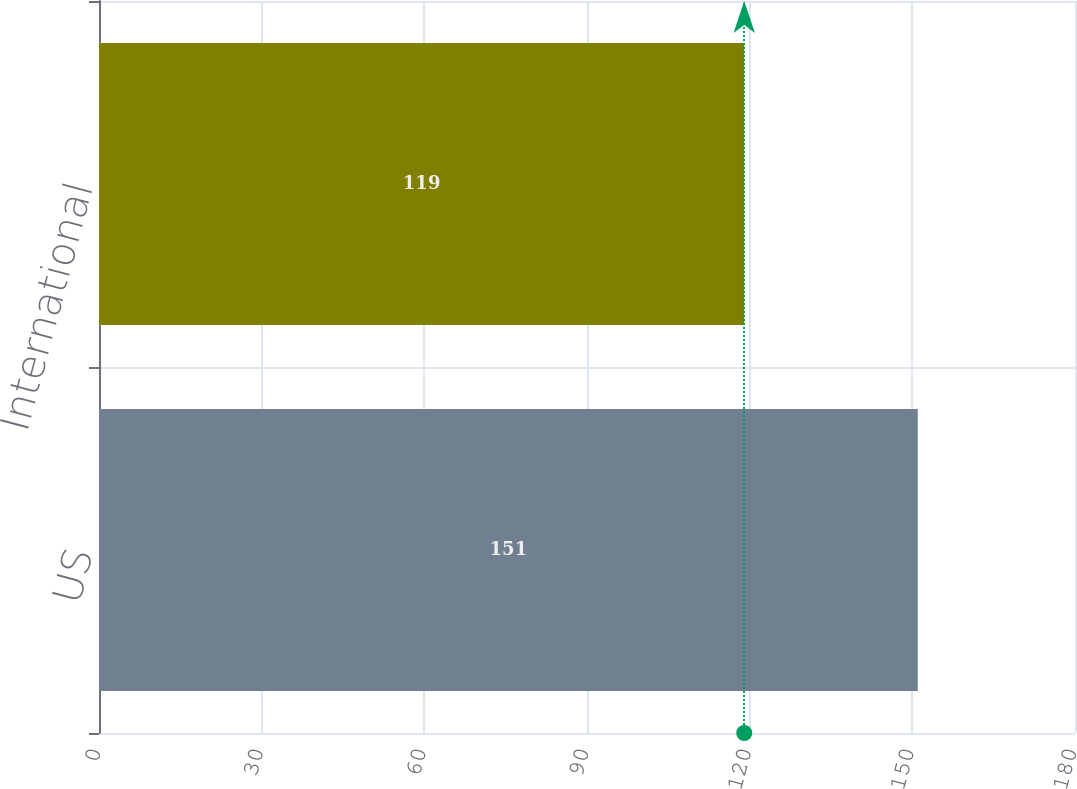<chart> <loc_0><loc_0><loc_500><loc_500><bar_chart><fcel>US<fcel>International<nl><fcel>151<fcel>119<nl></chart> 